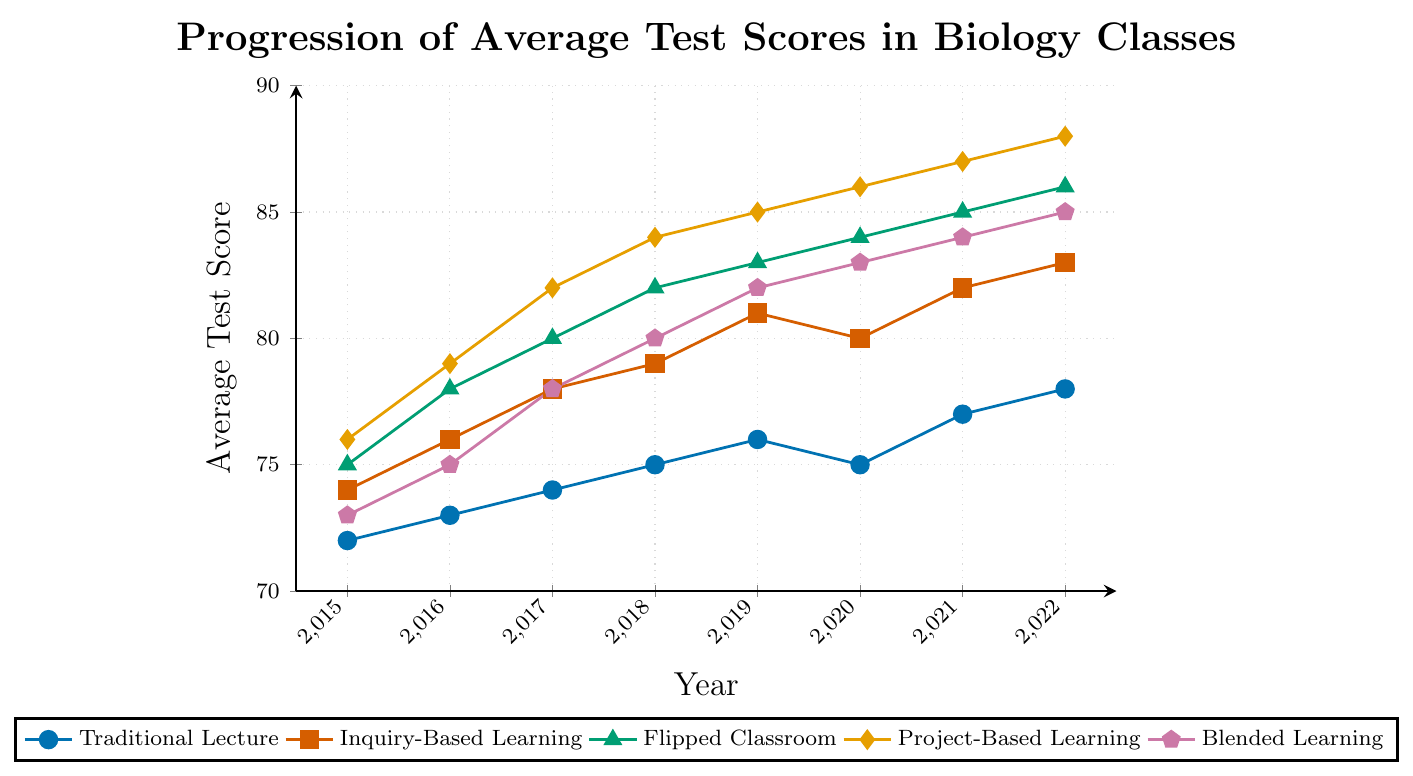What's the trend of test scores for 'Traditional Lecture' from 2015 to 2022? To identify the trend, observe the line representing 'Traditional Lecture' from 2015 to 2022. The test scores increase gradually from 72 in 2015 to 78 in 2022.
Answer: Increasing Which teaching method had the highest average test score in 2022? Look at the values for each teaching method in 2022. 'Project-Based Learning' has the highest score of 88.
Answer: Project-Based Learning How much did the average test score for 'Flipped Classroom' increase from 2015 to 2022? Find the difference between the test scores of 'Flipped Classroom' in 2015 and 2022: 86 - 75 = 11.
Answer: 11 Compare the average test scores of 'Inquiry-Based Learning' and 'Blended Learning' in 2019. Which method performed better? Compare the test scores for 'Inquiry-Based Learning' (81) and 'Blended Learning' (82) in 2019. 'Blended Learning' performed better.
Answer: Blended Learning What is the average test score for 'Project-Based Learning' between 2015 and 2022? Sum the test scores for each year and then divide by the number of years: (76 + 79 + 82 + 84 + 85 + 86 + 87 + 88) / 8 = 82.125.
Answer: 82.125 Which year saw the largest increase in 'Inquiry-Based Learning' scores compared to the previous year? Calculate the year-over-year differences: 
2016-2015: 76-74=2, 
2017-2016: 78-76=2, 
2018-2017: 79-78=1, 
2019-2018: 81-79=2, 
2020-2019: 80-81=(-1), 
2021-2020: 82-80=2, 
2022-2021: 83-82=1. 
The largest increase is 2, occurring in 2016-2015, 2017-2016, 2019-2018, and 2021-2022.
Answer: 2016, 2017, 2019, 2021 What color represents 'Blended Learning' in the chart? Identify the color associated with 'Blended Learning'. It is shown in blue.
Answer: Blue 